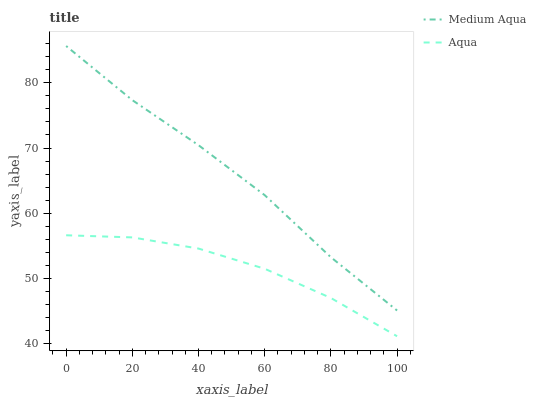Does Medium Aqua have the minimum area under the curve?
Answer yes or no. No. Is Medium Aqua the roughest?
Answer yes or no. No. Does Medium Aqua have the lowest value?
Answer yes or no. No. Is Aqua less than Medium Aqua?
Answer yes or no. Yes. Is Medium Aqua greater than Aqua?
Answer yes or no. Yes. Does Aqua intersect Medium Aqua?
Answer yes or no. No. 